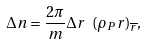<formula> <loc_0><loc_0><loc_500><loc_500>\Delta n = \frac { 2 \pi } { m } \Delta r \ ( \rho _ { P } r ) _ { \overline { r } } ,</formula> 